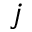<formula> <loc_0><loc_0><loc_500><loc_500>j</formula> 